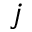<formula> <loc_0><loc_0><loc_500><loc_500>j</formula> 